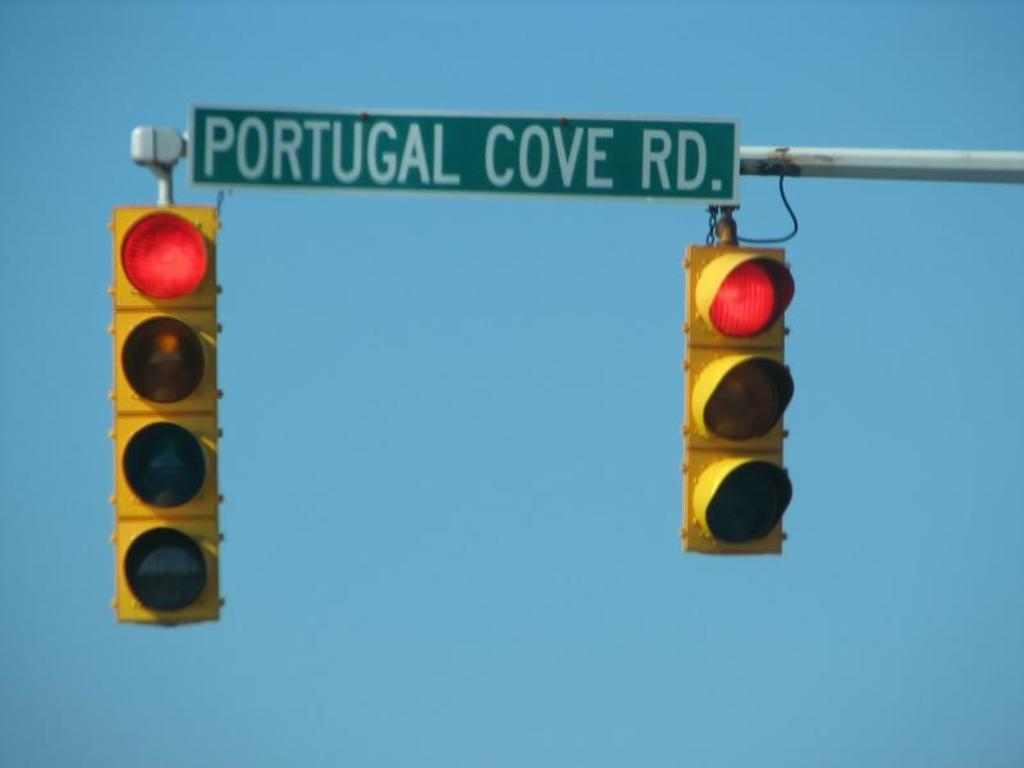<image>
Give a short and clear explanation of the subsequent image. The street lights are on red and it says PORTUGAL COVE RD. in between the at the top. 